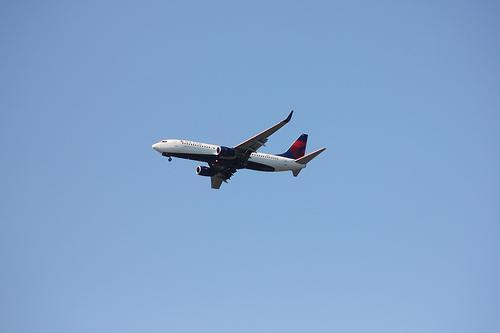How many airplanes are pictured?
Give a very brief answer. 1. 